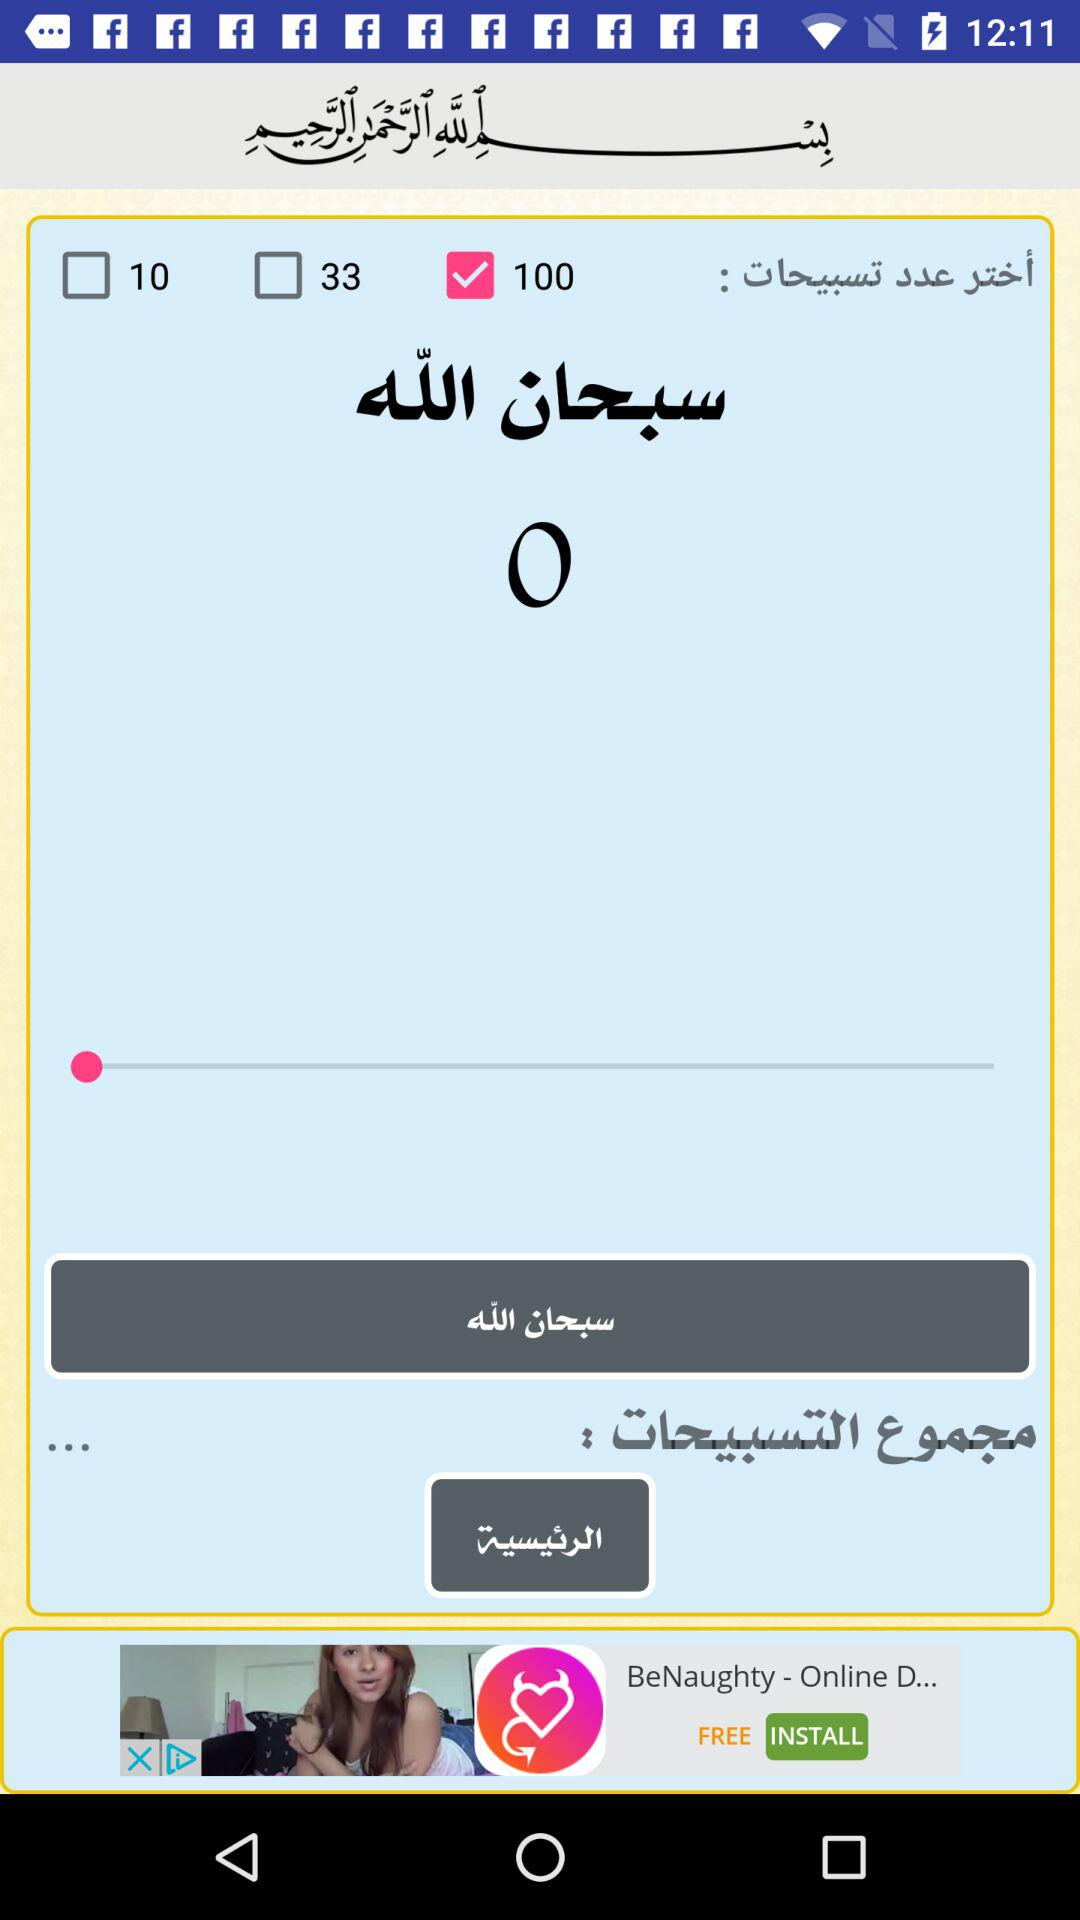How many more checkboxes are there than labels on the screen?
Answer the question using a single word or phrase. 2 